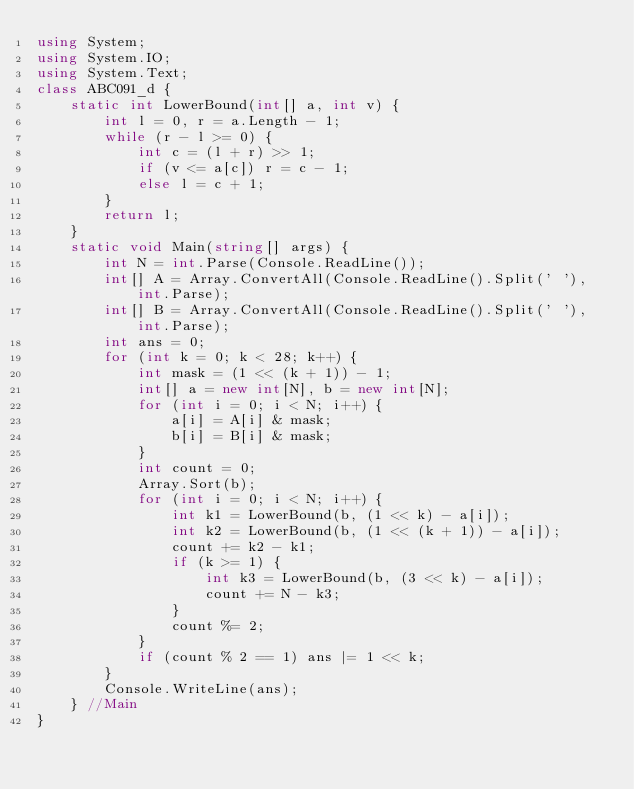<code> <loc_0><loc_0><loc_500><loc_500><_C#_>using System;
using System.IO;
using System.Text;
class ABC091_d {
    static int LowerBound(int[] a, int v) {
        int l = 0, r = a.Length - 1;
        while (r - l >= 0) {
            int c = (l + r) >> 1;
            if (v <= a[c]) r = c - 1;
            else l = c + 1;
        }
        return l;
    }
    static void Main(string[] args) {
        int N = int.Parse(Console.ReadLine());
        int[] A = Array.ConvertAll(Console.ReadLine().Split(' '), int.Parse);
        int[] B = Array.ConvertAll(Console.ReadLine().Split(' '), int.Parse);
        int ans = 0;
        for (int k = 0; k < 28; k++) {
            int mask = (1 << (k + 1)) - 1;
            int[] a = new int[N], b = new int[N];
            for (int i = 0; i < N; i++) {
                a[i] = A[i] & mask;
                b[i] = B[i] & mask;
            }
            int count = 0;
            Array.Sort(b);
            for (int i = 0; i < N; i++) {
                int k1 = LowerBound(b, (1 << k) - a[i]);
                int k2 = LowerBound(b, (1 << (k + 1)) - a[i]);
                count += k2 - k1;
                if (k >= 1) {
                    int k3 = LowerBound(b, (3 << k) - a[i]);
                    count += N - k3;
                }
                count %= 2;
            }
            if (count % 2 == 1) ans |= 1 << k;
        }
        Console.WriteLine(ans);
    } //Main
}
</code> 